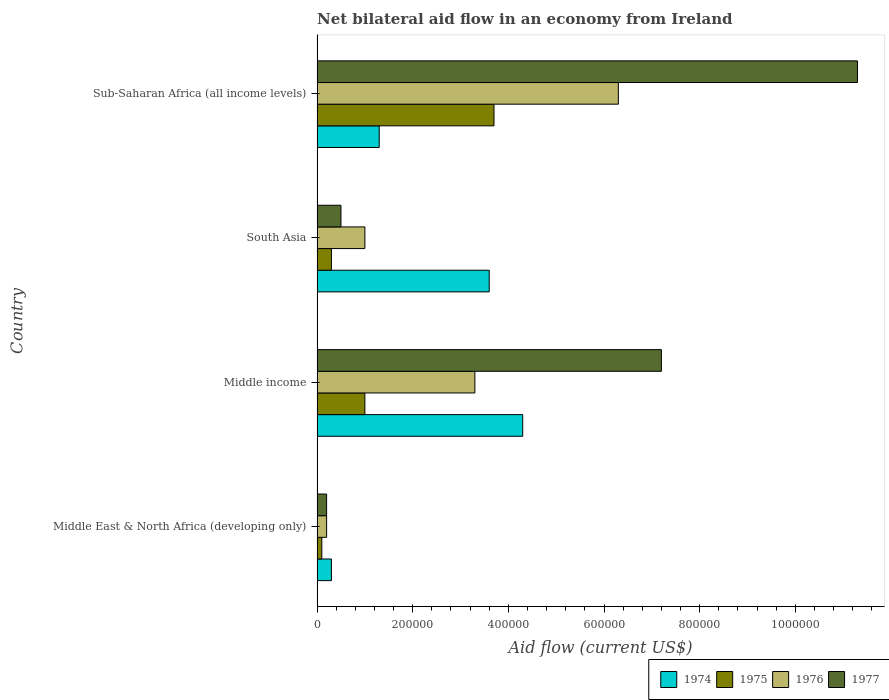How many different coloured bars are there?
Ensure brevity in your answer.  4. How many bars are there on the 3rd tick from the top?
Your answer should be compact. 4. How many bars are there on the 1st tick from the bottom?
Your answer should be compact. 4. What is the net bilateral aid flow in 1975 in Middle income?
Make the answer very short. 1.00e+05. Across all countries, what is the maximum net bilateral aid flow in 1976?
Your answer should be very brief. 6.30e+05. In which country was the net bilateral aid flow in 1975 maximum?
Ensure brevity in your answer.  Sub-Saharan Africa (all income levels). In which country was the net bilateral aid flow in 1975 minimum?
Your answer should be very brief. Middle East & North Africa (developing only). What is the total net bilateral aid flow in 1975 in the graph?
Keep it short and to the point. 5.10e+05. What is the difference between the net bilateral aid flow in 1975 in Middle income and that in South Asia?
Give a very brief answer. 7.00e+04. What is the ratio of the net bilateral aid flow in 1976 in Middle East & North Africa (developing only) to that in Middle income?
Make the answer very short. 0.06. Is the net bilateral aid flow in 1977 in Middle income less than that in South Asia?
Make the answer very short. No. What is the difference between the highest and the second highest net bilateral aid flow in 1976?
Keep it short and to the point. 3.00e+05. What is the difference between the highest and the lowest net bilateral aid flow in 1977?
Provide a succinct answer. 1.11e+06. What does the 3rd bar from the top in Middle income represents?
Offer a very short reply. 1975. What does the 3rd bar from the bottom in South Asia represents?
Your response must be concise. 1976. How many bars are there?
Your answer should be compact. 16. Are all the bars in the graph horizontal?
Give a very brief answer. Yes. How many countries are there in the graph?
Your response must be concise. 4. Does the graph contain any zero values?
Give a very brief answer. No. Where does the legend appear in the graph?
Provide a succinct answer. Bottom right. How many legend labels are there?
Your answer should be very brief. 4. How are the legend labels stacked?
Ensure brevity in your answer.  Horizontal. What is the title of the graph?
Provide a short and direct response. Net bilateral aid flow in an economy from Ireland. What is the label or title of the X-axis?
Keep it short and to the point. Aid flow (current US$). What is the Aid flow (current US$) in 1974 in Middle East & North Africa (developing only)?
Your answer should be compact. 3.00e+04. What is the Aid flow (current US$) of 1975 in Middle East & North Africa (developing only)?
Offer a very short reply. 10000. What is the Aid flow (current US$) in 1977 in Middle East & North Africa (developing only)?
Ensure brevity in your answer.  2.00e+04. What is the Aid flow (current US$) of 1974 in Middle income?
Your answer should be very brief. 4.30e+05. What is the Aid flow (current US$) in 1975 in Middle income?
Give a very brief answer. 1.00e+05. What is the Aid flow (current US$) of 1977 in Middle income?
Keep it short and to the point. 7.20e+05. What is the Aid flow (current US$) in 1976 in South Asia?
Give a very brief answer. 1.00e+05. What is the Aid flow (current US$) of 1974 in Sub-Saharan Africa (all income levels)?
Your answer should be compact. 1.30e+05. What is the Aid flow (current US$) of 1976 in Sub-Saharan Africa (all income levels)?
Offer a terse response. 6.30e+05. What is the Aid flow (current US$) in 1977 in Sub-Saharan Africa (all income levels)?
Your answer should be very brief. 1.13e+06. Across all countries, what is the maximum Aid flow (current US$) in 1974?
Make the answer very short. 4.30e+05. Across all countries, what is the maximum Aid flow (current US$) of 1976?
Make the answer very short. 6.30e+05. Across all countries, what is the maximum Aid flow (current US$) of 1977?
Make the answer very short. 1.13e+06. Across all countries, what is the minimum Aid flow (current US$) of 1974?
Make the answer very short. 3.00e+04. Across all countries, what is the minimum Aid flow (current US$) in 1976?
Your answer should be compact. 2.00e+04. Across all countries, what is the minimum Aid flow (current US$) of 1977?
Give a very brief answer. 2.00e+04. What is the total Aid flow (current US$) of 1974 in the graph?
Ensure brevity in your answer.  9.50e+05. What is the total Aid flow (current US$) in 1975 in the graph?
Provide a succinct answer. 5.10e+05. What is the total Aid flow (current US$) in 1976 in the graph?
Offer a terse response. 1.08e+06. What is the total Aid flow (current US$) of 1977 in the graph?
Provide a succinct answer. 1.92e+06. What is the difference between the Aid flow (current US$) in 1974 in Middle East & North Africa (developing only) and that in Middle income?
Your answer should be very brief. -4.00e+05. What is the difference between the Aid flow (current US$) in 1975 in Middle East & North Africa (developing only) and that in Middle income?
Ensure brevity in your answer.  -9.00e+04. What is the difference between the Aid flow (current US$) in 1976 in Middle East & North Africa (developing only) and that in Middle income?
Offer a very short reply. -3.10e+05. What is the difference between the Aid flow (current US$) in 1977 in Middle East & North Africa (developing only) and that in Middle income?
Your answer should be very brief. -7.00e+05. What is the difference between the Aid flow (current US$) in 1974 in Middle East & North Africa (developing only) and that in South Asia?
Provide a succinct answer. -3.30e+05. What is the difference between the Aid flow (current US$) in 1976 in Middle East & North Africa (developing only) and that in South Asia?
Give a very brief answer. -8.00e+04. What is the difference between the Aid flow (current US$) of 1975 in Middle East & North Africa (developing only) and that in Sub-Saharan Africa (all income levels)?
Give a very brief answer. -3.60e+05. What is the difference between the Aid flow (current US$) of 1976 in Middle East & North Africa (developing only) and that in Sub-Saharan Africa (all income levels)?
Your response must be concise. -6.10e+05. What is the difference between the Aid flow (current US$) in 1977 in Middle East & North Africa (developing only) and that in Sub-Saharan Africa (all income levels)?
Offer a very short reply. -1.11e+06. What is the difference between the Aid flow (current US$) in 1977 in Middle income and that in South Asia?
Provide a succinct answer. 6.70e+05. What is the difference between the Aid flow (current US$) of 1974 in Middle income and that in Sub-Saharan Africa (all income levels)?
Your answer should be compact. 3.00e+05. What is the difference between the Aid flow (current US$) in 1977 in Middle income and that in Sub-Saharan Africa (all income levels)?
Offer a very short reply. -4.10e+05. What is the difference between the Aid flow (current US$) of 1975 in South Asia and that in Sub-Saharan Africa (all income levels)?
Give a very brief answer. -3.40e+05. What is the difference between the Aid flow (current US$) of 1976 in South Asia and that in Sub-Saharan Africa (all income levels)?
Ensure brevity in your answer.  -5.30e+05. What is the difference between the Aid flow (current US$) of 1977 in South Asia and that in Sub-Saharan Africa (all income levels)?
Your response must be concise. -1.08e+06. What is the difference between the Aid flow (current US$) of 1974 in Middle East & North Africa (developing only) and the Aid flow (current US$) of 1975 in Middle income?
Your answer should be compact. -7.00e+04. What is the difference between the Aid flow (current US$) of 1974 in Middle East & North Africa (developing only) and the Aid flow (current US$) of 1977 in Middle income?
Ensure brevity in your answer.  -6.90e+05. What is the difference between the Aid flow (current US$) of 1975 in Middle East & North Africa (developing only) and the Aid flow (current US$) of 1976 in Middle income?
Give a very brief answer. -3.20e+05. What is the difference between the Aid flow (current US$) in 1975 in Middle East & North Africa (developing only) and the Aid flow (current US$) in 1977 in Middle income?
Your answer should be compact. -7.10e+05. What is the difference between the Aid flow (current US$) of 1976 in Middle East & North Africa (developing only) and the Aid flow (current US$) of 1977 in Middle income?
Provide a succinct answer. -7.00e+05. What is the difference between the Aid flow (current US$) of 1974 in Middle East & North Africa (developing only) and the Aid flow (current US$) of 1976 in South Asia?
Make the answer very short. -7.00e+04. What is the difference between the Aid flow (current US$) of 1974 in Middle East & North Africa (developing only) and the Aid flow (current US$) of 1976 in Sub-Saharan Africa (all income levels)?
Offer a terse response. -6.00e+05. What is the difference between the Aid flow (current US$) in 1974 in Middle East & North Africa (developing only) and the Aid flow (current US$) in 1977 in Sub-Saharan Africa (all income levels)?
Ensure brevity in your answer.  -1.10e+06. What is the difference between the Aid flow (current US$) in 1975 in Middle East & North Africa (developing only) and the Aid flow (current US$) in 1976 in Sub-Saharan Africa (all income levels)?
Make the answer very short. -6.20e+05. What is the difference between the Aid flow (current US$) in 1975 in Middle East & North Africa (developing only) and the Aid flow (current US$) in 1977 in Sub-Saharan Africa (all income levels)?
Offer a terse response. -1.12e+06. What is the difference between the Aid flow (current US$) in 1976 in Middle East & North Africa (developing only) and the Aid flow (current US$) in 1977 in Sub-Saharan Africa (all income levels)?
Make the answer very short. -1.11e+06. What is the difference between the Aid flow (current US$) of 1974 in Middle income and the Aid flow (current US$) of 1976 in South Asia?
Offer a terse response. 3.30e+05. What is the difference between the Aid flow (current US$) of 1975 in Middle income and the Aid flow (current US$) of 1976 in South Asia?
Provide a short and direct response. 0. What is the difference between the Aid flow (current US$) in 1976 in Middle income and the Aid flow (current US$) in 1977 in South Asia?
Provide a short and direct response. 2.80e+05. What is the difference between the Aid flow (current US$) in 1974 in Middle income and the Aid flow (current US$) in 1977 in Sub-Saharan Africa (all income levels)?
Ensure brevity in your answer.  -7.00e+05. What is the difference between the Aid flow (current US$) of 1975 in Middle income and the Aid flow (current US$) of 1976 in Sub-Saharan Africa (all income levels)?
Offer a very short reply. -5.30e+05. What is the difference between the Aid flow (current US$) in 1975 in Middle income and the Aid flow (current US$) in 1977 in Sub-Saharan Africa (all income levels)?
Ensure brevity in your answer.  -1.03e+06. What is the difference between the Aid flow (current US$) in 1976 in Middle income and the Aid flow (current US$) in 1977 in Sub-Saharan Africa (all income levels)?
Make the answer very short. -8.00e+05. What is the difference between the Aid flow (current US$) of 1974 in South Asia and the Aid flow (current US$) of 1976 in Sub-Saharan Africa (all income levels)?
Make the answer very short. -2.70e+05. What is the difference between the Aid flow (current US$) in 1974 in South Asia and the Aid flow (current US$) in 1977 in Sub-Saharan Africa (all income levels)?
Offer a terse response. -7.70e+05. What is the difference between the Aid flow (current US$) of 1975 in South Asia and the Aid flow (current US$) of 1976 in Sub-Saharan Africa (all income levels)?
Keep it short and to the point. -6.00e+05. What is the difference between the Aid flow (current US$) in 1975 in South Asia and the Aid flow (current US$) in 1977 in Sub-Saharan Africa (all income levels)?
Give a very brief answer. -1.10e+06. What is the difference between the Aid flow (current US$) of 1976 in South Asia and the Aid flow (current US$) of 1977 in Sub-Saharan Africa (all income levels)?
Offer a very short reply. -1.03e+06. What is the average Aid flow (current US$) in 1974 per country?
Provide a short and direct response. 2.38e+05. What is the average Aid flow (current US$) of 1975 per country?
Make the answer very short. 1.28e+05. What is the average Aid flow (current US$) of 1976 per country?
Provide a short and direct response. 2.70e+05. What is the difference between the Aid flow (current US$) in 1974 and Aid flow (current US$) in 1975 in Middle East & North Africa (developing only)?
Keep it short and to the point. 2.00e+04. What is the difference between the Aid flow (current US$) in 1975 and Aid flow (current US$) in 1976 in Middle East & North Africa (developing only)?
Offer a very short reply. -10000. What is the difference between the Aid flow (current US$) in 1976 and Aid flow (current US$) in 1977 in Middle East & North Africa (developing only)?
Your answer should be very brief. 0. What is the difference between the Aid flow (current US$) in 1974 and Aid flow (current US$) in 1977 in Middle income?
Keep it short and to the point. -2.90e+05. What is the difference between the Aid flow (current US$) of 1975 and Aid flow (current US$) of 1977 in Middle income?
Provide a short and direct response. -6.20e+05. What is the difference between the Aid flow (current US$) in 1976 and Aid flow (current US$) in 1977 in Middle income?
Give a very brief answer. -3.90e+05. What is the difference between the Aid flow (current US$) of 1974 and Aid flow (current US$) of 1975 in South Asia?
Give a very brief answer. 3.30e+05. What is the difference between the Aid flow (current US$) in 1975 and Aid flow (current US$) in 1976 in South Asia?
Offer a very short reply. -7.00e+04. What is the difference between the Aid flow (current US$) in 1974 and Aid flow (current US$) in 1976 in Sub-Saharan Africa (all income levels)?
Give a very brief answer. -5.00e+05. What is the difference between the Aid flow (current US$) in 1975 and Aid flow (current US$) in 1977 in Sub-Saharan Africa (all income levels)?
Your answer should be very brief. -7.60e+05. What is the difference between the Aid flow (current US$) of 1976 and Aid flow (current US$) of 1977 in Sub-Saharan Africa (all income levels)?
Keep it short and to the point. -5.00e+05. What is the ratio of the Aid flow (current US$) in 1974 in Middle East & North Africa (developing only) to that in Middle income?
Your answer should be compact. 0.07. What is the ratio of the Aid flow (current US$) in 1976 in Middle East & North Africa (developing only) to that in Middle income?
Offer a terse response. 0.06. What is the ratio of the Aid flow (current US$) in 1977 in Middle East & North Africa (developing only) to that in Middle income?
Offer a very short reply. 0.03. What is the ratio of the Aid flow (current US$) in 1974 in Middle East & North Africa (developing only) to that in South Asia?
Your answer should be compact. 0.08. What is the ratio of the Aid flow (current US$) of 1974 in Middle East & North Africa (developing only) to that in Sub-Saharan Africa (all income levels)?
Give a very brief answer. 0.23. What is the ratio of the Aid flow (current US$) in 1975 in Middle East & North Africa (developing only) to that in Sub-Saharan Africa (all income levels)?
Give a very brief answer. 0.03. What is the ratio of the Aid flow (current US$) in 1976 in Middle East & North Africa (developing only) to that in Sub-Saharan Africa (all income levels)?
Offer a very short reply. 0.03. What is the ratio of the Aid flow (current US$) of 1977 in Middle East & North Africa (developing only) to that in Sub-Saharan Africa (all income levels)?
Keep it short and to the point. 0.02. What is the ratio of the Aid flow (current US$) of 1974 in Middle income to that in South Asia?
Your answer should be compact. 1.19. What is the ratio of the Aid flow (current US$) of 1975 in Middle income to that in South Asia?
Your answer should be very brief. 3.33. What is the ratio of the Aid flow (current US$) of 1974 in Middle income to that in Sub-Saharan Africa (all income levels)?
Your response must be concise. 3.31. What is the ratio of the Aid flow (current US$) in 1975 in Middle income to that in Sub-Saharan Africa (all income levels)?
Give a very brief answer. 0.27. What is the ratio of the Aid flow (current US$) of 1976 in Middle income to that in Sub-Saharan Africa (all income levels)?
Give a very brief answer. 0.52. What is the ratio of the Aid flow (current US$) in 1977 in Middle income to that in Sub-Saharan Africa (all income levels)?
Ensure brevity in your answer.  0.64. What is the ratio of the Aid flow (current US$) of 1974 in South Asia to that in Sub-Saharan Africa (all income levels)?
Your response must be concise. 2.77. What is the ratio of the Aid flow (current US$) of 1975 in South Asia to that in Sub-Saharan Africa (all income levels)?
Provide a short and direct response. 0.08. What is the ratio of the Aid flow (current US$) in 1976 in South Asia to that in Sub-Saharan Africa (all income levels)?
Give a very brief answer. 0.16. What is the ratio of the Aid flow (current US$) in 1977 in South Asia to that in Sub-Saharan Africa (all income levels)?
Your answer should be very brief. 0.04. What is the difference between the highest and the lowest Aid flow (current US$) of 1976?
Give a very brief answer. 6.10e+05. What is the difference between the highest and the lowest Aid flow (current US$) of 1977?
Make the answer very short. 1.11e+06. 